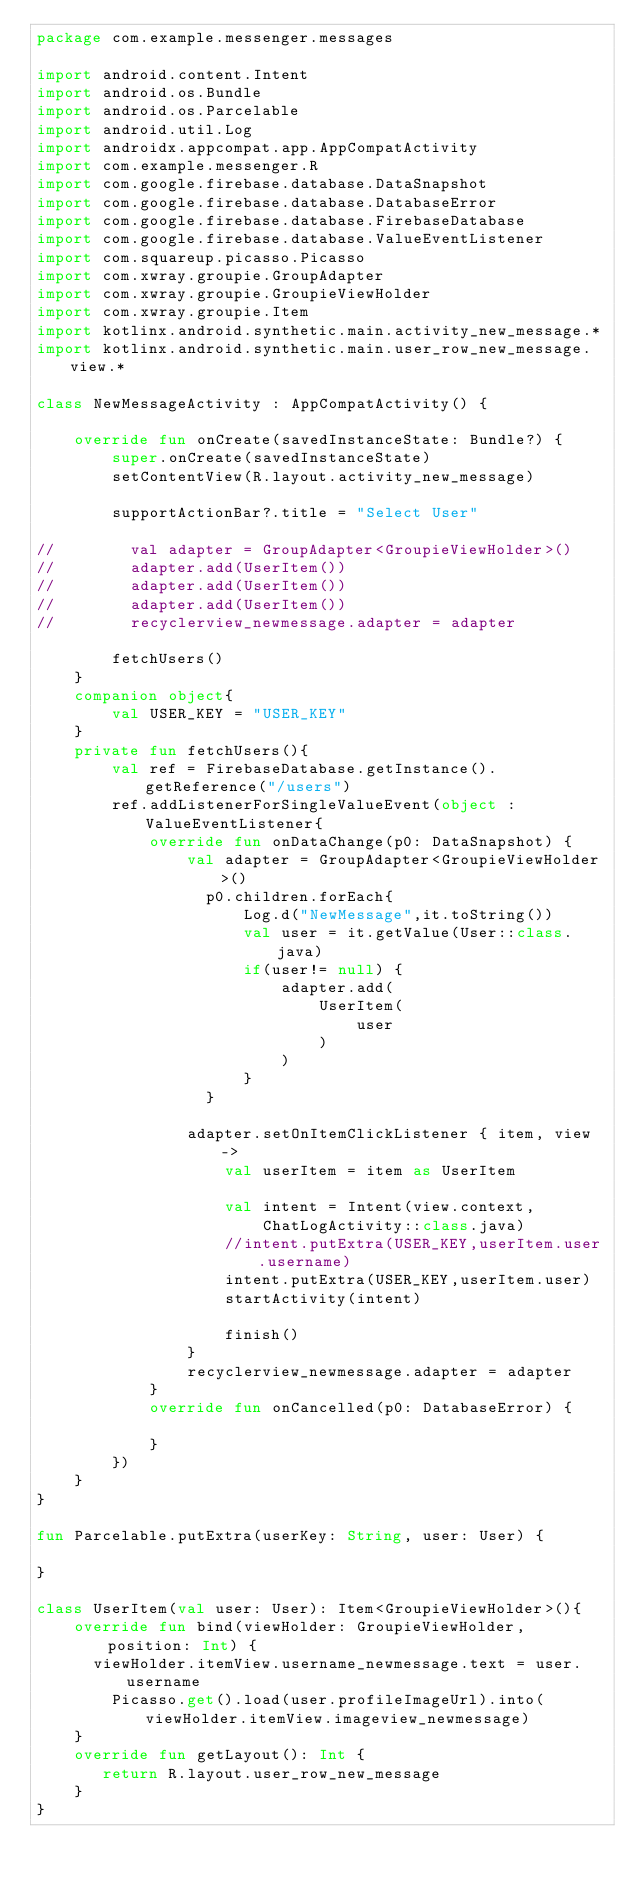<code> <loc_0><loc_0><loc_500><loc_500><_Kotlin_>package com.example.messenger.messages

import android.content.Intent
import android.os.Bundle
import android.os.Parcelable
import android.util.Log
import androidx.appcompat.app.AppCompatActivity
import com.example.messenger.R
import com.google.firebase.database.DataSnapshot
import com.google.firebase.database.DatabaseError
import com.google.firebase.database.FirebaseDatabase
import com.google.firebase.database.ValueEventListener
import com.squareup.picasso.Picasso
import com.xwray.groupie.GroupAdapter
import com.xwray.groupie.GroupieViewHolder
import com.xwray.groupie.Item
import kotlinx.android.synthetic.main.activity_new_message.*
import kotlinx.android.synthetic.main.user_row_new_message.view.*

class NewMessageActivity : AppCompatActivity() {

    override fun onCreate(savedInstanceState: Bundle?) {
        super.onCreate(savedInstanceState)
        setContentView(R.layout.activity_new_message)

        supportActionBar?.title = "Select User"

//        val adapter = GroupAdapter<GroupieViewHolder>()
//        adapter.add(UserItem())
//        adapter.add(UserItem())
//        adapter.add(UserItem())
//        recyclerview_newmessage.adapter = adapter

        fetchUsers()
    }
    companion object{
        val USER_KEY = "USER_KEY"
    }
    private fun fetchUsers(){
        val ref = FirebaseDatabase.getInstance().getReference("/users")
        ref.addListenerForSingleValueEvent(object : ValueEventListener{
            override fun onDataChange(p0: DataSnapshot) {
                val adapter = GroupAdapter<GroupieViewHolder>()
                  p0.children.forEach{
                      Log.d("NewMessage",it.toString())
                      val user = it.getValue(User::class.java)
                      if(user!= null) {
                          adapter.add(
                              UserItem(
                                  user
                              )
                          )
                      }
                  }

                adapter.setOnItemClickListener { item, view ->
                    val userItem = item as UserItem

                    val intent = Intent(view.context,
                        ChatLogActivity::class.java)
                    //intent.putExtra(USER_KEY,userItem.user.username)
                    intent.putExtra(USER_KEY,userItem.user)
                    startActivity(intent)

                    finish()
                }
                recyclerview_newmessage.adapter = adapter
            }
            override fun onCancelled(p0: DatabaseError) {

            }
        })
    }
}

fun Parcelable.putExtra(userKey: String, user: User) {

}

class UserItem(val user: User): Item<GroupieViewHolder>(){
    override fun bind(viewHolder: GroupieViewHolder, position: Int) {
      viewHolder.itemView.username_newmessage.text = user.username
        Picasso.get().load(user.profileImageUrl).into(viewHolder.itemView.imageview_newmessage)
    }
    override fun getLayout(): Int {
       return R.layout.user_row_new_message
    }
}

</code> 